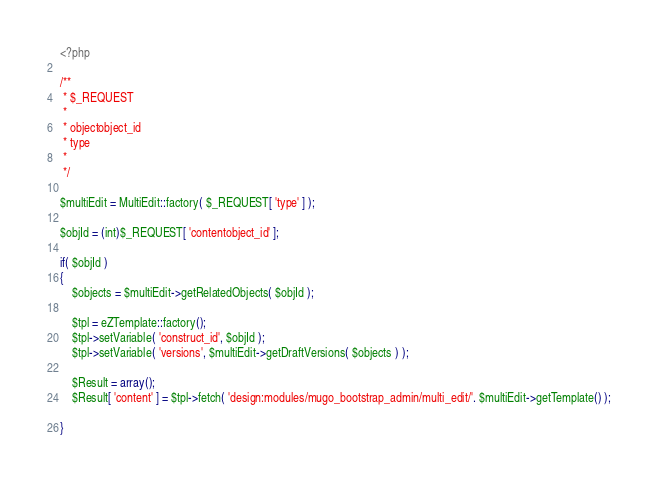<code> <loc_0><loc_0><loc_500><loc_500><_PHP_><?php

/**
 * $_REQUEST
 *
 * objectobject_id
 * type
 *
 */

$multiEdit = MultiEdit::factory( $_REQUEST[ 'type' ] );

$objId = (int)$_REQUEST[ 'contentobject_id' ];

if( $objId )
{
    $objects = $multiEdit->getRelatedObjects( $objId );

    $tpl = eZTemplate::factory();
    $tpl->setVariable( 'construct_id', $objId );
    $tpl->setVariable( 'versions', $multiEdit->getDraftVersions( $objects ) );

    $Result = array();
    $Result[ 'content' ] = $tpl->fetch( 'design:modules/mugo_bootstrap_admin/multi_edit/'. $multiEdit->getTemplate() );

}

</code> 